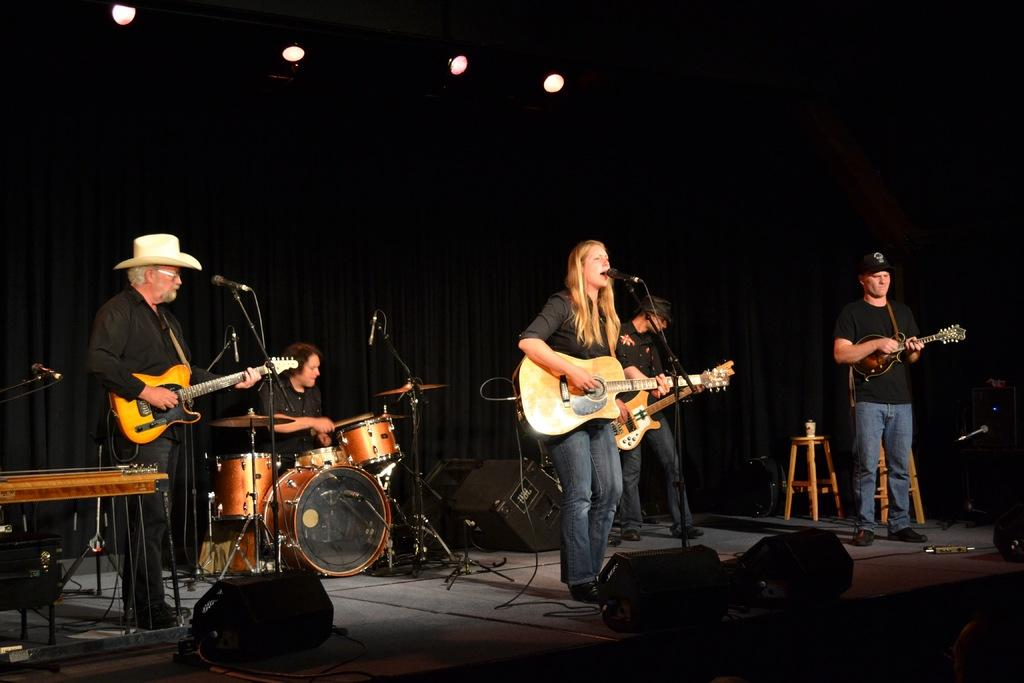What is happening in the image? There is a group of people in the image, and they are playing musical instruments (guitar and drums). What can be seen near the group of people? There is a microphone in front of the group of people. What type of plough is being used by the friend in the image? There is no plough or friend present in the image; it features a group of people playing musical instruments and a microphone. 